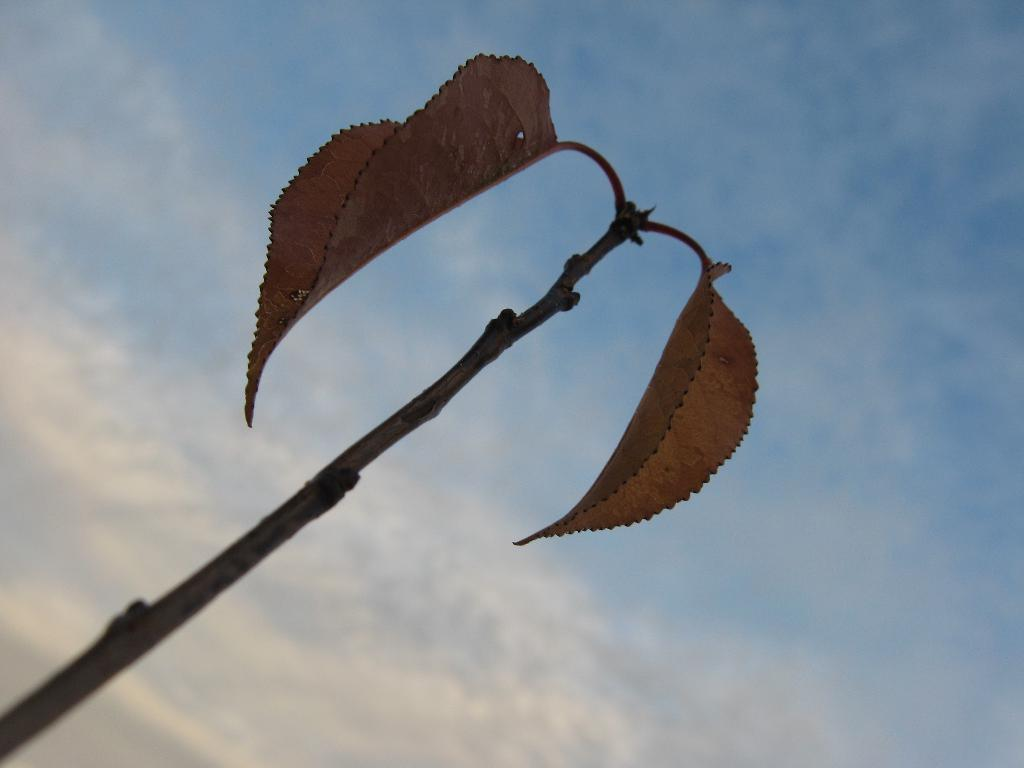What is located in the foreground of the image? There is a stem in the foreground of the image. What else can be seen in the image besides the stem? There are leaves in the image. What is visible in the background of the image? The sky is visible in the image. Can you describe the sky in the image? The sky appears to be slightly cloudy. What type of leather material can be seen in the image? There is no leather material present in the image. Is there a stream visible in the image? There is no stream visible in the image. 